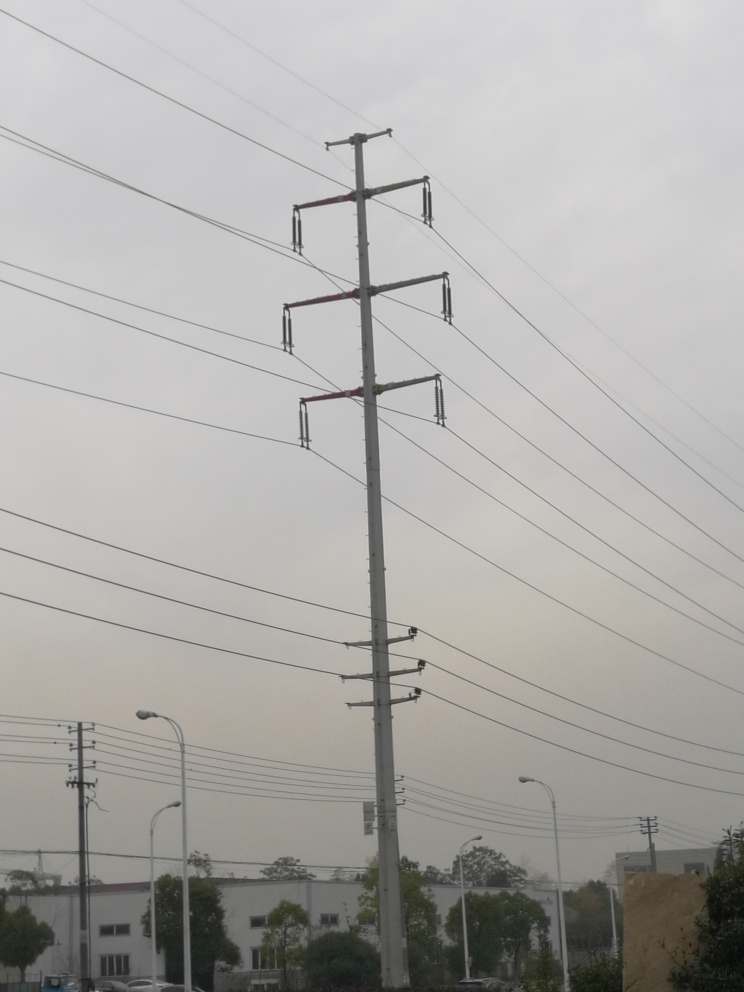Is the background sharp? The background appears soft and slightly out of focus, which is likely due to atmospheric conditions such as mist or haze. There is a discernible lack of sharpness in the finer details of the landscape behind the power lines. 